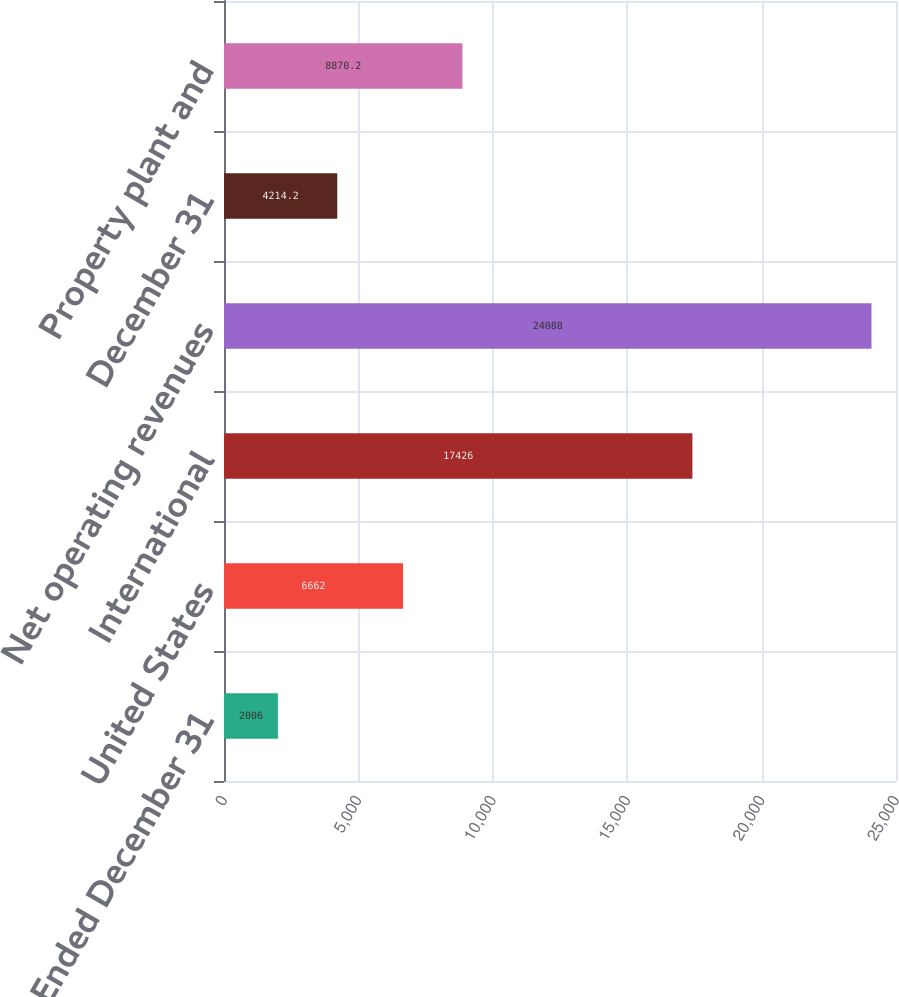Convert chart. <chart><loc_0><loc_0><loc_500><loc_500><bar_chart><fcel>Year Ended December 31<fcel>United States<fcel>International<fcel>Net operating revenues<fcel>December 31<fcel>Property plant and<nl><fcel>2006<fcel>6662<fcel>17426<fcel>24088<fcel>4214.2<fcel>8870.2<nl></chart> 